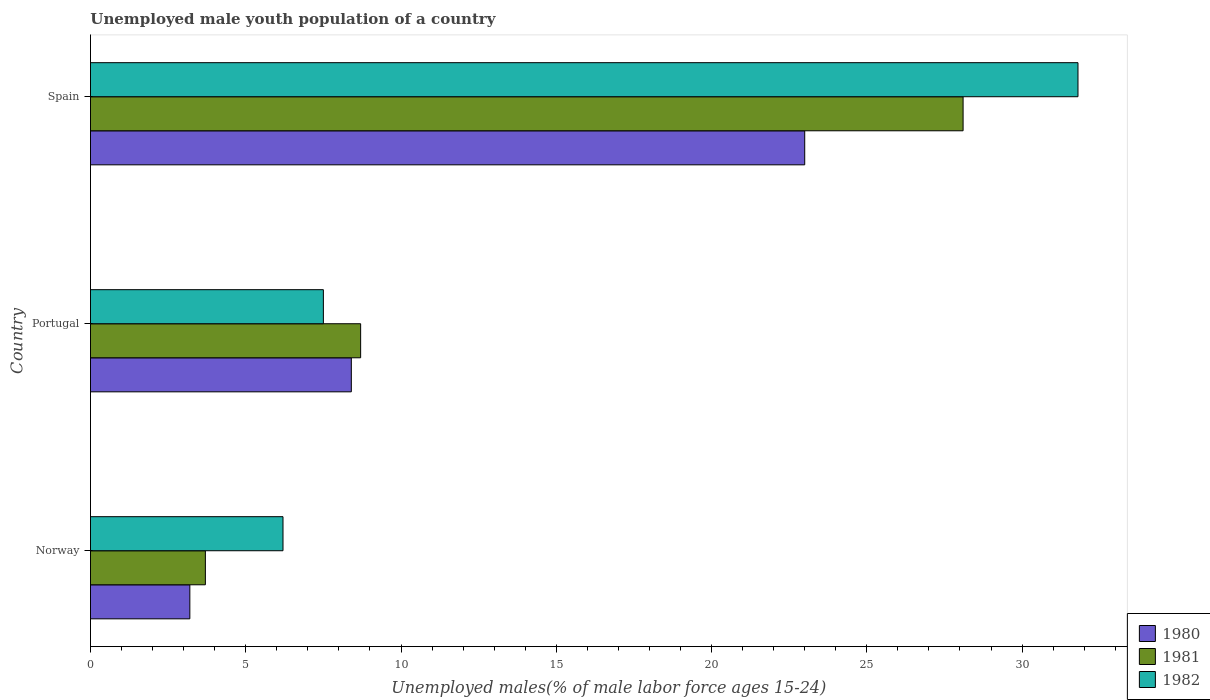How many different coloured bars are there?
Ensure brevity in your answer.  3. How many groups of bars are there?
Give a very brief answer. 3. Are the number of bars per tick equal to the number of legend labels?
Give a very brief answer. Yes. Are the number of bars on each tick of the Y-axis equal?
Your answer should be compact. Yes. In how many cases, is the number of bars for a given country not equal to the number of legend labels?
Keep it short and to the point. 0. What is the percentage of unemployed male youth population in 1981 in Portugal?
Offer a very short reply. 8.7. Across all countries, what is the maximum percentage of unemployed male youth population in 1982?
Ensure brevity in your answer.  31.8. Across all countries, what is the minimum percentage of unemployed male youth population in 1981?
Your answer should be very brief. 3.7. In which country was the percentage of unemployed male youth population in 1980 maximum?
Your response must be concise. Spain. In which country was the percentage of unemployed male youth population in 1981 minimum?
Your answer should be compact. Norway. What is the total percentage of unemployed male youth population in 1980 in the graph?
Keep it short and to the point. 34.6. What is the difference between the percentage of unemployed male youth population in 1980 in Portugal and that in Spain?
Ensure brevity in your answer.  -14.6. What is the difference between the percentage of unemployed male youth population in 1982 in Norway and the percentage of unemployed male youth population in 1980 in Portugal?
Provide a short and direct response. -2.2. What is the average percentage of unemployed male youth population in 1982 per country?
Provide a succinct answer. 15.17. What is the difference between the percentage of unemployed male youth population in 1981 and percentage of unemployed male youth population in 1980 in Portugal?
Provide a short and direct response. 0.3. In how many countries, is the percentage of unemployed male youth population in 1980 greater than 14 %?
Provide a short and direct response. 1. What is the ratio of the percentage of unemployed male youth population in 1982 in Norway to that in Spain?
Offer a terse response. 0.19. Is the percentage of unemployed male youth population in 1981 in Norway less than that in Portugal?
Provide a short and direct response. Yes. What is the difference between the highest and the second highest percentage of unemployed male youth population in 1980?
Your answer should be compact. 14.6. What is the difference between the highest and the lowest percentage of unemployed male youth population in 1980?
Provide a succinct answer. 19.8. Are all the bars in the graph horizontal?
Provide a succinct answer. Yes. How many countries are there in the graph?
Make the answer very short. 3. What is the difference between two consecutive major ticks on the X-axis?
Offer a terse response. 5. Does the graph contain any zero values?
Make the answer very short. No. How many legend labels are there?
Your answer should be compact. 3. What is the title of the graph?
Make the answer very short. Unemployed male youth population of a country. What is the label or title of the X-axis?
Provide a short and direct response. Unemployed males(% of male labor force ages 15-24). What is the Unemployed males(% of male labor force ages 15-24) of 1980 in Norway?
Make the answer very short. 3.2. What is the Unemployed males(% of male labor force ages 15-24) of 1981 in Norway?
Offer a terse response. 3.7. What is the Unemployed males(% of male labor force ages 15-24) of 1982 in Norway?
Offer a terse response. 6.2. What is the Unemployed males(% of male labor force ages 15-24) of 1980 in Portugal?
Ensure brevity in your answer.  8.4. What is the Unemployed males(% of male labor force ages 15-24) in 1981 in Portugal?
Give a very brief answer. 8.7. What is the Unemployed males(% of male labor force ages 15-24) of 1982 in Portugal?
Provide a succinct answer. 7.5. What is the Unemployed males(% of male labor force ages 15-24) in 1980 in Spain?
Keep it short and to the point. 23. What is the Unemployed males(% of male labor force ages 15-24) in 1981 in Spain?
Provide a succinct answer. 28.1. What is the Unemployed males(% of male labor force ages 15-24) in 1982 in Spain?
Your answer should be very brief. 31.8. Across all countries, what is the maximum Unemployed males(% of male labor force ages 15-24) of 1981?
Your answer should be compact. 28.1. Across all countries, what is the maximum Unemployed males(% of male labor force ages 15-24) in 1982?
Your answer should be compact. 31.8. Across all countries, what is the minimum Unemployed males(% of male labor force ages 15-24) of 1980?
Your response must be concise. 3.2. Across all countries, what is the minimum Unemployed males(% of male labor force ages 15-24) in 1981?
Offer a very short reply. 3.7. Across all countries, what is the minimum Unemployed males(% of male labor force ages 15-24) in 1982?
Your response must be concise. 6.2. What is the total Unemployed males(% of male labor force ages 15-24) in 1980 in the graph?
Keep it short and to the point. 34.6. What is the total Unemployed males(% of male labor force ages 15-24) in 1981 in the graph?
Your response must be concise. 40.5. What is the total Unemployed males(% of male labor force ages 15-24) in 1982 in the graph?
Your answer should be compact. 45.5. What is the difference between the Unemployed males(% of male labor force ages 15-24) of 1980 in Norway and that in Portugal?
Ensure brevity in your answer.  -5.2. What is the difference between the Unemployed males(% of male labor force ages 15-24) in 1982 in Norway and that in Portugal?
Keep it short and to the point. -1.3. What is the difference between the Unemployed males(% of male labor force ages 15-24) of 1980 in Norway and that in Spain?
Make the answer very short. -19.8. What is the difference between the Unemployed males(% of male labor force ages 15-24) of 1981 in Norway and that in Spain?
Offer a terse response. -24.4. What is the difference between the Unemployed males(% of male labor force ages 15-24) of 1982 in Norway and that in Spain?
Your response must be concise. -25.6. What is the difference between the Unemployed males(% of male labor force ages 15-24) in 1980 in Portugal and that in Spain?
Offer a terse response. -14.6. What is the difference between the Unemployed males(% of male labor force ages 15-24) in 1981 in Portugal and that in Spain?
Your answer should be very brief. -19.4. What is the difference between the Unemployed males(% of male labor force ages 15-24) in 1982 in Portugal and that in Spain?
Ensure brevity in your answer.  -24.3. What is the difference between the Unemployed males(% of male labor force ages 15-24) in 1981 in Norway and the Unemployed males(% of male labor force ages 15-24) in 1982 in Portugal?
Your answer should be very brief. -3.8. What is the difference between the Unemployed males(% of male labor force ages 15-24) in 1980 in Norway and the Unemployed males(% of male labor force ages 15-24) in 1981 in Spain?
Your response must be concise. -24.9. What is the difference between the Unemployed males(% of male labor force ages 15-24) of 1980 in Norway and the Unemployed males(% of male labor force ages 15-24) of 1982 in Spain?
Give a very brief answer. -28.6. What is the difference between the Unemployed males(% of male labor force ages 15-24) in 1981 in Norway and the Unemployed males(% of male labor force ages 15-24) in 1982 in Spain?
Ensure brevity in your answer.  -28.1. What is the difference between the Unemployed males(% of male labor force ages 15-24) of 1980 in Portugal and the Unemployed males(% of male labor force ages 15-24) of 1981 in Spain?
Your answer should be very brief. -19.7. What is the difference between the Unemployed males(% of male labor force ages 15-24) of 1980 in Portugal and the Unemployed males(% of male labor force ages 15-24) of 1982 in Spain?
Make the answer very short. -23.4. What is the difference between the Unemployed males(% of male labor force ages 15-24) in 1981 in Portugal and the Unemployed males(% of male labor force ages 15-24) in 1982 in Spain?
Your answer should be compact. -23.1. What is the average Unemployed males(% of male labor force ages 15-24) in 1980 per country?
Give a very brief answer. 11.53. What is the average Unemployed males(% of male labor force ages 15-24) in 1981 per country?
Give a very brief answer. 13.5. What is the average Unemployed males(% of male labor force ages 15-24) in 1982 per country?
Offer a very short reply. 15.17. What is the difference between the Unemployed males(% of male labor force ages 15-24) of 1981 and Unemployed males(% of male labor force ages 15-24) of 1982 in Norway?
Keep it short and to the point. -2.5. What is the difference between the Unemployed males(% of male labor force ages 15-24) of 1981 and Unemployed males(% of male labor force ages 15-24) of 1982 in Portugal?
Your answer should be compact. 1.2. What is the difference between the Unemployed males(% of male labor force ages 15-24) in 1980 and Unemployed males(% of male labor force ages 15-24) in 1981 in Spain?
Provide a short and direct response. -5.1. What is the difference between the Unemployed males(% of male labor force ages 15-24) in 1980 and Unemployed males(% of male labor force ages 15-24) in 1982 in Spain?
Your response must be concise. -8.8. What is the difference between the Unemployed males(% of male labor force ages 15-24) in 1981 and Unemployed males(% of male labor force ages 15-24) in 1982 in Spain?
Ensure brevity in your answer.  -3.7. What is the ratio of the Unemployed males(% of male labor force ages 15-24) of 1980 in Norway to that in Portugal?
Ensure brevity in your answer.  0.38. What is the ratio of the Unemployed males(% of male labor force ages 15-24) of 1981 in Norway to that in Portugal?
Your answer should be very brief. 0.43. What is the ratio of the Unemployed males(% of male labor force ages 15-24) of 1982 in Norway to that in Portugal?
Offer a very short reply. 0.83. What is the ratio of the Unemployed males(% of male labor force ages 15-24) of 1980 in Norway to that in Spain?
Keep it short and to the point. 0.14. What is the ratio of the Unemployed males(% of male labor force ages 15-24) of 1981 in Norway to that in Spain?
Give a very brief answer. 0.13. What is the ratio of the Unemployed males(% of male labor force ages 15-24) of 1982 in Norway to that in Spain?
Ensure brevity in your answer.  0.2. What is the ratio of the Unemployed males(% of male labor force ages 15-24) in 1980 in Portugal to that in Spain?
Provide a succinct answer. 0.37. What is the ratio of the Unemployed males(% of male labor force ages 15-24) in 1981 in Portugal to that in Spain?
Your response must be concise. 0.31. What is the ratio of the Unemployed males(% of male labor force ages 15-24) in 1982 in Portugal to that in Spain?
Ensure brevity in your answer.  0.24. What is the difference between the highest and the second highest Unemployed males(% of male labor force ages 15-24) of 1981?
Your answer should be compact. 19.4. What is the difference between the highest and the second highest Unemployed males(% of male labor force ages 15-24) in 1982?
Your answer should be very brief. 24.3. What is the difference between the highest and the lowest Unemployed males(% of male labor force ages 15-24) of 1980?
Offer a terse response. 19.8. What is the difference between the highest and the lowest Unemployed males(% of male labor force ages 15-24) in 1981?
Your response must be concise. 24.4. What is the difference between the highest and the lowest Unemployed males(% of male labor force ages 15-24) of 1982?
Offer a very short reply. 25.6. 